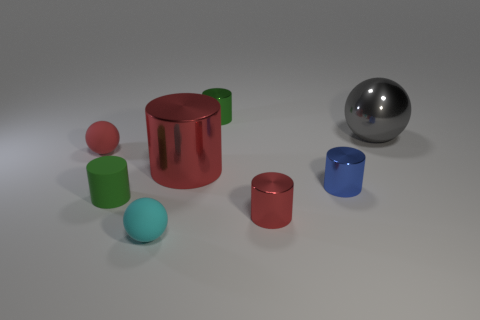Are there an equal number of small red things that are in front of the red sphere and big yellow metallic cylinders?
Your response must be concise. No. How many objects are either tiny metallic things in front of the red matte object or large red metal things?
Make the answer very short. 3. There is a tiny metal thing that is behind the green matte cylinder and in front of the large gray object; what is its shape?
Offer a very short reply. Cylinder. What number of objects are either small red things that are left of the green matte cylinder or tiny green cylinders behind the big gray object?
Keep it short and to the point. 2. What number of other objects are the same size as the blue shiny object?
Keep it short and to the point. 5. There is a matte object behind the green matte cylinder; does it have the same color as the metallic sphere?
Your answer should be very brief. No. What size is the object that is to the right of the red matte ball and to the left of the cyan rubber sphere?
Provide a short and direct response. Small. What number of tiny objects are either red spheres or blue cylinders?
Offer a very short reply. 2. There is a large metallic object that is in front of the large gray metal thing; what shape is it?
Offer a terse response. Cylinder. What number of large metal cylinders are there?
Give a very brief answer. 1. 